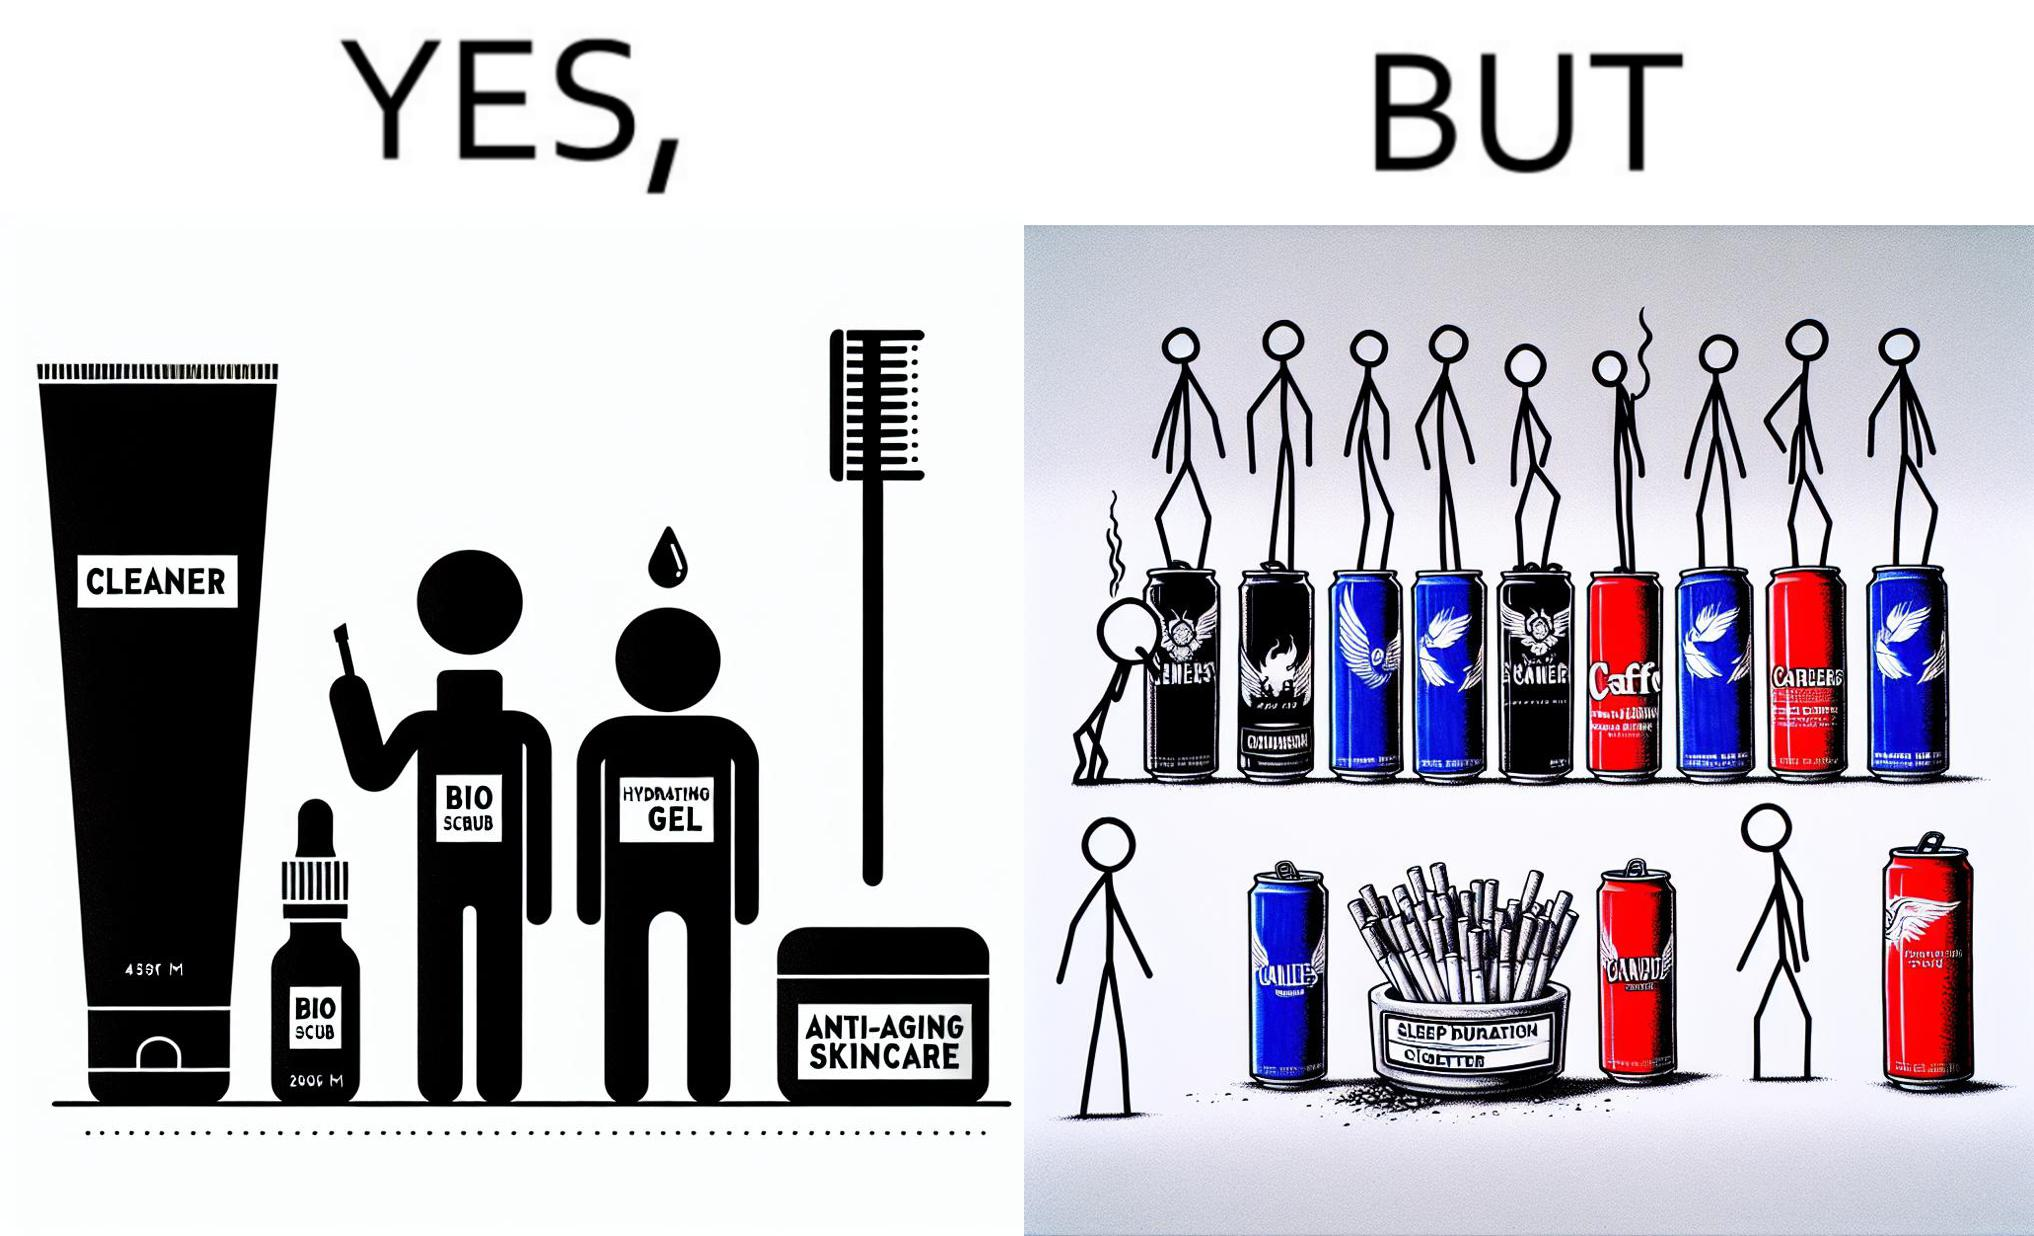What does this image depict? This image is ironic as on the one hand, the presumed person is into skincare and wants to do the best for their skin, which is good, but on the other hand, they are involved in unhealthy habits that will damage their skin like smoking, caffeine and inadequate sleep. 